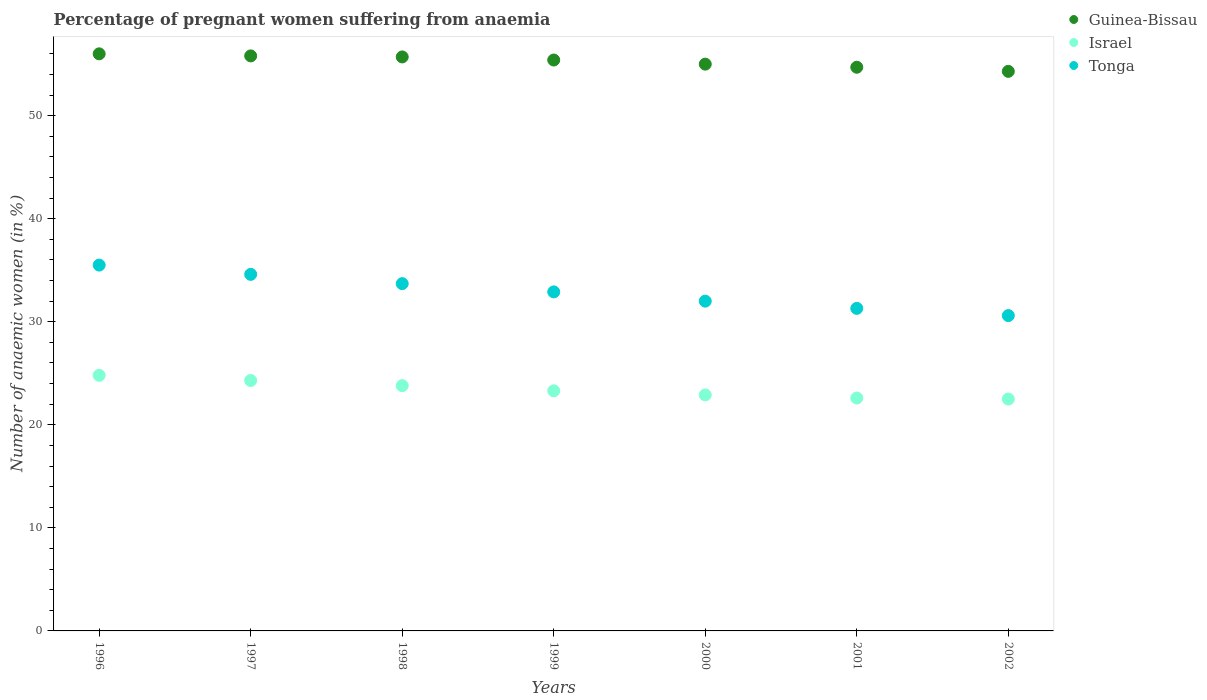How many different coloured dotlines are there?
Provide a succinct answer. 3. Is the number of dotlines equal to the number of legend labels?
Your answer should be very brief. Yes. What is the number of anaemic women in Guinea-Bissau in 2002?
Your answer should be very brief. 54.3. Across all years, what is the minimum number of anaemic women in Guinea-Bissau?
Your answer should be very brief. 54.3. In which year was the number of anaemic women in Tonga maximum?
Your answer should be very brief. 1996. What is the total number of anaemic women in Guinea-Bissau in the graph?
Your response must be concise. 386.9. What is the difference between the number of anaemic women in Israel in 2000 and that in 2001?
Your answer should be compact. 0.3. What is the difference between the number of anaemic women in Tonga in 1998 and the number of anaemic women in Guinea-Bissau in 2002?
Keep it short and to the point. -20.6. What is the average number of anaemic women in Israel per year?
Keep it short and to the point. 23.46. In the year 1998, what is the difference between the number of anaemic women in Guinea-Bissau and number of anaemic women in Israel?
Offer a very short reply. 31.9. In how many years, is the number of anaemic women in Guinea-Bissau greater than 18 %?
Your answer should be very brief. 7. What is the ratio of the number of anaemic women in Israel in 1998 to that in 2002?
Provide a short and direct response. 1.06. Is the number of anaemic women in Tonga in 1997 less than that in 1999?
Your answer should be compact. No. What is the difference between the highest and the second highest number of anaemic women in Guinea-Bissau?
Provide a succinct answer. 0.2. What is the difference between the highest and the lowest number of anaemic women in Tonga?
Give a very brief answer. 4.9. In how many years, is the number of anaemic women in Israel greater than the average number of anaemic women in Israel taken over all years?
Give a very brief answer. 3. How many years are there in the graph?
Offer a terse response. 7. What is the title of the graph?
Your answer should be very brief. Percentage of pregnant women suffering from anaemia. What is the label or title of the Y-axis?
Give a very brief answer. Number of anaemic women (in %). What is the Number of anaemic women (in %) in Israel in 1996?
Your answer should be compact. 24.8. What is the Number of anaemic women (in %) of Tonga in 1996?
Offer a very short reply. 35.5. What is the Number of anaemic women (in %) of Guinea-Bissau in 1997?
Ensure brevity in your answer.  55.8. What is the Number of anaemic women (in %) in Israel in 1997?
Provide a short and direct response. 24.3. What is the Number of anaemic women (in %) in Tonga in 1997?
Offer a very short reply. 34.6. What is the Number of anaemic women (in %) in Guinea-Bissau in 1998?
Give a very brief answer. 55.7. What is the Number of anaemic women (in %) in Israel in 1998?
Your answer should be very brief. 23.8. What is the Number of anaemic women (in %) in Tonga in 1998?
Keep it short and to the point. 33.7. What is the Number of anaemic women (in %) in Guinea-Bissau in 1999?
Offer a very short reply. 55.4. What is the Number of anaemic women (in %) of Israel in 1999?
Your response must be concise. 23.3. What is the Number of anaemic women (in %) of Tonga in 1999?
Your response must be concise. 32.9. What is the Number of anaemic women (in %) in Guinea-Bissau in 2000?
Offer a terse response. 55. What is the Number of anaemic women (in %) of Israel in 2000?
Give a very brief answer. 22.9. What is the Number of anaemic women (in %) of Guinea-Bissau in 2001?
Offer a terse response. 54.7. What is the Number of anaemic women (in %) in Israel in 2001?
Offer a terse response. 22.6. What is the Number of anaemic women (in %) of Tonga in 2001?
Make the answer very short. 31.3. What is the Number of anaemic women (in %) in Guinea-Bissau in 2002?
Make the answer very short. 54.3. What is the Number of anaemic women (in %) of Tonga in 2002?
Ensure brevity in your answer.  30.6. Across all years, what is the maximum Number of anaemic women (in %) of Israel?
Offer a terse response. 24.8. Across all years, what is the maximum Number of anaemic women (in %) in Tonga?
Provide a succinct answer. 35.5. Across all years, what is the minimum Number of anaemic women (in %) in Guinea-Bissau?
Give a very brief answer. 54.3. Across all years, what is the minimum Number of anaemic women (in %) in Israel?
Your answer should be very brief. 22.5. Across all years, what is the minimum Number of anaemic women (in %) of Tonga?
Provide a short and direct response. 30.6. What is the total Number of anaemic women (in %) in Guinea-Bissau in the graph?
Offer a very short reply. 386.9. What is the total Number of anaemic women (in %) in Israel in the graph?
Your response must be concise. 164.2. What is the total Number of anaemic women (in %) in Tonga in the graph?
Give a very brief answer. 230.6. What is the difference between the Number of anaemic women (in %) in Guinea-Bissau in 1996 and that in 1997?
Your answer should be very brief. 0.2. What is the difference between the Number of anaemic women (in %) of Tonga in 1996 and that in 1997?
Provide a short and direct response. 0.9. What is the difference between the Number of anaemic women (in %) in Israel in 1996 and that in 1998?
Provide a succinct answer. 1. What is the difference between the Number of anaemic women (in %) of Guinea-Bissau in 1996 and that in 1999?
Keep it short and to the point. 0.6. What is the difference between the Number of anaemic women (in %) in Tonga in 1996 and that in 1999?
Make the answer very short. 2.6. What is the difference between the Number of anaemic women (in %) of Tonga in 1996 and that in 2000?
Offer a terse response. 3.5. What is the difference between the Number of anaemic women (in %) in Tonga in 1996 and that in 2001?
Make the answer very short. 4.2. What is the difference between the Number of anaemic women (in %) in Guinea-Bissau in 1996 and that in 2002?
Your response must be concise. 1.7. What is the difference between the Number of anaemic women (in %) of Israel in 1997 and that in 1999?
Keep it short and to the point. 1. What is the difference between the Number of anaemic women (in %) in Tonga in 1997 and that in 1999?
Keep it short and to the point. 1.7. What is the difference between the Number of anaemic women (in %) in Guinea-Bissau in 1997 and that in 2000?
Offer a terse response. 0.8. What is the difference between the Number of anaemic women (in %) of Israel in 1997 and that in 2000?
Offer a very short reply. 1.4. What is the difference between the Number of anaemic women (in %) of Tonga in 1997 and that in 2000?
Provide a short and direct response. 2.6. What is the difference between the Number of anaemic women (in %) in Tonga in 1997 and that in 2001?
Provide a succinct answer. 3.3. What is the difference between the Number of anaemic women (in %) in Israel in 1997 and that in 2002?
Offer a terse response. 1.8. What is the difference between the Number of anaemic women (in %) in Tonga in 1998 and that in 1999?
Offer a terse response. 0.8. What is the difference between the Number of anaemic women (in %) of Guinea-Bissau in 1998 and that in 2000?
Provide a succinct answer. 0.7. What is the difference between the Number of anaemic women (in %) in Israel in 1998 and that in 2001?
Offer a terse response. 1.2. What is the difference between the Number of anaemic women (in %) in Israel in 1998 and that in 2002?
Provide a succinct answer. 1.3. What is the difference between the Number of anaemic women (in %) of Tonga in 1999 and that in 2000?
Make the answer very short. 0.9. What is the difference between the Number of anaemic women (in %) of Israel in 1999 and that in 2001?
Keep it short and to the point. 0.7. What is the difference between the Number of anaemic women (in %) of Israel in 1999 and that in 2002?
Your answer should be very brief. 0.8. What is the difference between the Number of anaemic women (in %) in Guinea-Bissau in 2000 and that in 2001?
Ensure brevity in your answer.  0.3. What is the difference between the Number of anaemic women (in %) in Tonga in 2000 and that in 2001?
Provide a short and direct response. 0.7. What is the difference between the Number of anaemic women (in %) of Israel in 2000 and that in 2002?
Ensure brevity in your answer.  0.4. What is the difference between the Number of anaemic women (in %) in Tonga in 2001 and that in 2002?
Give a very brief answer. 0.7. What is the difference between the Number of anaemic women (in %) of Guinea-Bissau in 1996 and the Number of anaemic women (in %) of Israel in 1997?
Your answer should be compact. 31.7. What is the difference between the Number of anaemic women (in %) in Guinea-Bissau in 1996 and the Number of anaemic women (in %) in Tonga in 1997?
Give a very brief answer. 21.4. What is the difference between the Number of anaemic women (in %) of Israel in 1996 and the Number of anaemic women (in %) of Tonga in 1997?
Provide a succinct answer. -9.8. What is the difference between the Number of anaemic women (in %) in Guinea-Bissau in 1996 and the Number of anaemic women (in %) in Israel in 1998?
Offer a terse response. 32.2. What is the difference between the Number of anaemic women (in %) in Guinea-Bissau in 1996 and the Number of anaemic women (in %) in Tonga in 1998?
Offer a very short reply. 22.3. What is the difference between the Number of anaemic women (in %) of Guinea-Bissau in 1996 and the Number of anaemic women (in %) of Israel in 1999?
Offer a very short reply. 32.7. What is the difference between the Number of anaemic women (in %) of Guinea-Bissau in 1996 and the Number of anaemic women (in %) of Tonga in 1999?
Provide a short and direct response. 23.1. What is the difference between the Number of anaemic women (in %) in Israel in 1996 and the Number of anaemic women (in %) in Tonga in 1999?
Keep it short and to the point. -8.1. What is the difference between the Number of anaemic women (in %) in Guinea-Bissau in 1996 and the Number of anaemic women (in %) in Israel in 2000?
Offer a very short reply. 33.1. What is the difference between the Number of anaemic women (in %) of Guinea-Bissau in 1996 and the Number of anaemic women (in %) of Tonga in 2000?
Offer a very short reply. 24. What is the difference between the Number of anaemic women (in %) of Israel in 1996 and the Number of anaemic women (in %) of Tonga in 2000?
Make the answer very short. -7.2. What is the difference between the Number of anaemic women (in %) of Guinea-Bissau in 1996 and the Number of anaemic women (in %) of Israel in 2001?
Your answer should be compact. 33.4. What is the difference between the Number of anaemic women (in %) in Guinea-Bissau in 1996 and the Number of anaemic women (in %) in Tonga in 2001?
Make the answer very short. 24.7. What is the difference between the Number of anaemic women (in %) in Guinea-Bissau in 1996 and the Number of anaemic women (in %) in Israel in 2002?
Give a very brief answer. 33.5. What is the difference between the Number of anaemic women (in %) of Guinea-Bissau in 1996 and the Number of anaemic women (in %) of Tonga in 2002?
Make the answer very short. 25.4. What is the difference between the Number of anaemic women (in %) of Israel in 1996 and the Number of anaemic women (in %) of Tonga in 2002?
Your answer should be compact. -5.8. What is the difference between the Number of anaemic women (in %) in Guinea-Bissau in 1997 and the Number of anaemic women (in %) in Tonga in 1998?
Your answer should be compact. 22.1. What is the difference between the Number of anaemic women (in %) in Israel in 1997 and the Number of anaemic women (in %) in Tonga in 1998?
Your answer should be very brief. -9.4. What is the difference between the Number of anaemic women (in %) of Guinea-Bissau in 1997 and the Number of anaemic women (in %) of Israel in 1999?
Ensure brevity in your answer.  32.5. What is the difference between the Number of anaemic women (in %) in Guinea-Bissau in 1997 and the Number of anaemic women (in %) in Tonga in 1999?
Offer a very short reply. 22.9. What is the difference between the Number of anaemic women (in %) of Guinea-Bissau in 1997 and the Number of anaemic women (in %) of Israel in 2000?
Provide a short and direct response. 32.9. What is the difference between the Number of anaemic women (in %) of Guinea-Bissau in 1997 and the Number of anaemic women (in %) of Tonga in 2000?
Make the answer very short. 23.8. What is the difference between the Number of anaemic women (in %) of Guinea-Bissau in 1997 and the Number of anaemic women (in %) of Israel in 2001?
Offer a terse response. 33.2. What is the difference between the Number of anaemic women (in %) in Israel in 1997 and the Number of anaemic women (in %) in Tonga in 2001?
Provide a short and direct response. -7. What is the difference between the Number of anaemic women (in %) of Guinea-Bissau in 1997 and the Number of anaemic women (in %) of Israel in 2002?
Offer a terse response. 33.3. What is the difference between the Number of anaemic women (in %) of Guinea-Bissau in 1997 and the Number of anaemic women (in %) of Tonga in 2002?
Your answer should be very brief. 25.2. What is the difference between the Number of anaemic women (in %) of Guinea-Bissau in 1998 and the Number of anaemic women (in %) of Israel in 1999?
Give a very brief answer. 32.4. What is the difference between the Number of anaemic women (in %) in Guinea-Bissau in 1998 and the Number of anaemic women (in %) in Tonga in 1999?
Offer a very short reply. 22.8. What is the difference between the Number of anaemic women (in %) in Israel in 1998 and the Number of anaemic women (in %) in Tonga in 1999?
Make the answer very short. -9.1. What is the difference between the Number of anaemic women (in %) of Guinea-Bissau in 1998 and the Number of anaemic women (in %) of Israel in 2000?
Offer a terse response. 32.8. What is the difference between the Number of anaemic women (in %) of Guinea-Bissau in 1998 and the Number of anaemic women (in %) of Tonga in 2000?
Ensure brevity in your answer.  23.7. What is the difference between the Number of anaemic women (in %) in Guinea-Bissau in 1998 and the Number of anaemic women (in %) in Israel in 2001?
Offer a very short reply. 33.1. What is the difference between the Number of anaemic women (in %) of Guinea-Bissau in 1998 and the Number of anaemic women (in %) of Tonga in 2001?
Ensure brevity in your answer.  24.4. What is the difference between the Number of anaemic women (in %) of Guinea-Bissau in 1998 and the Number of anaemic women (in %) of Israel in 2002?
Provide a short and direct response. 33.2. What is the difference between the Number of anaemic women (in %) in Guinea-Bissau in 1998 and the Number of anaemic women (in %) in Tonga in 2002?
Keep it short and to the point. 25.1. What is the difference between the Number of anaemic women (in %) in Guinea-Bissau in 1999 and the Number of anaemic women (in %) in Israel in 2000?
Make the answer very short. 32.5. What is the difference between the Number of anaemic women (in %) in Guinea-Bissau in 1999 and the Number of anaemic women (in %) in Tonga in 2000?
Give a very brief answer. 23.4. What is the difference between the Number of anaemic women (in %) of Israel in 1999 and the Number of anaemic women (in %) of Tonga in 2000?
Offer a terse response. -8.7. What is the difference between the Number of anaemic women (in %) in Guinea-Bissau in 1999 and the Number of anaemic women (in %) in Israel in 2001?
Provide a short and direct response. 32.8. What is the difference between the Number of anaemic women (in %) in Guinea-Bissau in 1999 and the Number of anaemic women (in %) in Tonga in 2001?
Offer a very short reply. 24.1. What is the difference between the Number of anaemic women (in %) in Guinea-Bissau in 1999 and the Number of anaemic women (in %) in Israel in 2002?
Your response must be concise. 32.9. What is the difference between the Number of anaemic women (in %) of Guinea-Bissau in 1999 and the Number of anaemic women (in %) of Tonga in 2002?
Provide a succinct answer. 24.8. What is the difference between the Number of anaemic women (in %) in Israel in 1999 and the Number of anaemic women (in %) in Tonga in 2002?
Make the answer very short. -7.3. What is the difference between the Number of anaemic women (in %) of Guinea-Bissau in 2000 and the Number of anaemic women (in %) of Israel in 2001?
Offer a very short reply. 32.4. What is the difference between the Number of anaemic women (in %) in Guinea-Bissau in 2000 and the Number of anaemic women (in %) in Tonga in 2001?
Provide a succinct answer. 23.7. What is the difference between the Number of anaemic women (in %) in Israel in 2000 and the Number of anaemic women (in %) in Tonga in 2001?
Your response must be concise. -8.4. What is the difference between the Number of anaemic women (in %) in Guinea-Bissau in 2000 and the Number of anaemic women (in %) in Israel in 2002?
Provide a short and direct response. 32.5. What is the difference between the Number of anaemic women (in %) in Guinea-Bissau in 2000 and the Number of anaemic women (in %) in Tonga in 2002?
Offer a terse response. 24.4. What is the difference between the Number of anaemic women (in %) of Guinea-Bissau in 2001 and the Number of anaemic women (in %) of Israel in 2002?
Make the answer very short. 32.2. What is the difference between the Number of anaemic women (in %) in Guinea-Bissau in 2001 and the Number of anaemic women (in %) in Tonga in 2002?
Ensure brevity in your answer.  24.1. What is the difference between the Number of anaemic women (in %) of Israel in 2001 and the Number of anaemic women (in %) of Tonga in 2002?
Your response must be concise. -8. What is the average Number of anaemic women (in %) in Guinea-Bissau per year?
Make the answer very short. 55.27. What is the average Number of anaemic women (in %) of Israel per year?
Offer a terse response. 23.46. What is the average Number of anaemic women (in %) of Tonga per year?
Your response must be concise. 32.94. In the year 1996, what is the difference between the Number of anaemic women (in %) of Guinea-Bissau and Number of anaemic women (in %) of Israel?
Provide a succinct answer. 31.2. In the year 1997, what is the difference between the Number of anaemic women (in %) of Guinea-Bissau and Number of anaemic women (in %) of Israel?
Your answer should be very brief. 31.5. In the year 1997, what is the difference between the Number of anaemic women (in %) of Guinea-Bissau and Number of anaemic women (in %) of Tonga?
Give a very brief answer. 21.2. In the year 1998, what is the difference between the Number of anaemic women (in %) of Guinea-Bissau and Number of anaemic women (in %) of Israel?
Give a very brief answer. 31.9. In the year 1999, what is the difference between the Number of anaemic women (in %) in Guinea-Bissau and Number of anaemic women (in %) in Israel?
Provide a short and direct response. 32.1. In the year 1999, what is the difference between the Number of anaemic women (in %) of Guinea-Bissau and Number of anaemic women (in %) of Tonga?
Give a very brief answer. 22.5. In the year 2000, what is the difference between the Number of anaemic women (in %) of Guinea-Bissau and Number of anaemic women (in %) of Israel?
Your answer should be compact. 32.1. In the year 2000, what is the difference between the Number of anaemic women (in %) of Guinea-Bissau and Number of anaemic women (in %) of Tonga?
Provide a succinct answer. 23. In the year 2000, what is the difference between the Number of anaemic women (in %) of Israel and Number of anaemic women (in %) of Tonga?
Make the answer very short. -9.1. In the year 2001, what is the difference between the Number of anaemic women (in %) in Guinea-Bissau and Number of anaemic women (in %) in Israel?
Give a very brief answer. 32.1. In the year 2001, what is the difference between the Number of anaemic women (in %) of Guinea-Bissau and Number of anaemic women (in %) of Tonga?
Give a very brief answer. 23.4. In the year 2002, what is the difference between the Number of anaemic women (in %) in Guinea-Bissau and Number of anaemic women (in %) in Israel?
Offer a terse response. 31.8. In the year 2002, what is the difference between the Number of anaemic women (in %) in Guinea-Bissau and Number of anaemic women (in %) in Tonga?
Make the answer very short. 23.7. What is the ratio of the Number of anaemic women (in %) in Israel in 1996 to that in 1997?
Provide a short and direct response. 1.02. What is the ratio of the Number of anaemic women (in %) of Guinea-Bissau in 1996 to that in 1998?
Give a very brief answer. 1.01. What is the ratio of the Number of anaemic women (in %) in Israel in 1996 to that in 1998?
Provide a succinct answer. 1.04. What is the ratio of the Number of anaemic women (in %) of Tonga in 1996 to that in 1998?
Offer a terse response. 1.05. What is the ratio of the Number of anaemic women (in %) of Guinea-Bissau in 1996 to that in 1999?
Your answer should be very brief. 1.01. What is the ratio of the Number of anaemic women (in %) of Israel in 1996 to that in 1999?
Your answer should be compact. 1.06. What is the ratio of the Number of anaemic women (in %) of Tonga in 1996 to that in 1999?
Offer a terse response. 1.08. What is the ratio of the Number of anaemic women (in %) in Guinea-Bissau in 1996 to that in 2000?
Your answer should be very brief. 1.02. What is the ratio of the Number of anaemic women (in %) of Israel in 1996 to that in 2000?
Ensure brevity in your answer.  1.08. What is the ratio of the Number of anaemic women (in %) in Tonga in 1996 to that in 2000?
Your response must be concise. 1.11. What is the ratio of the Number of anaemic women (in %) of Guinea-Bissau in 1996 to that in 2001?
Provide a short and direct response. 1.02. What is the ratio of the Number of anaemic women (in %) of Israel in 1996 to that in 2001?
Provide a succinct answer. 1.1. What is the ratio of the Number of anaemic women (in %) in Tonga in 1996 to that in 2001?
Ensure brevity in your answer.  1.13. What is the ratio of the Number of anaemic women (in %) of Guinea-Bissau in 1996 to that in 2002?
Provide a short and direct response. 1.03. What is the ratio of the Number of anaemic women (in %) of Israel in 1996 to that in 2002?
Your answer should be very brief. 1.1. What is the ratio of the Number of anaemic women (in %) of Tonga in 1996 to that in 2002?
Keep it short and to the point. 1.16. What is the ratio of the Number of anaemic women (in %) of Guinea-Bissau in 1997 to that in 1998?
Offer a terse response. 1. What is the ratio of the Number of anaemic women (in %) of Tonga in 1997 to that in 1998?
Your answer should be compact. 1.03. What is the ratio of the Number of anaemic women (in %) in Israel in 1997 to that in 1999?
Give a very brief answer. 1.04. What is the ratio of the Number of anaemic women (in %) of Tonga in 1997 to that in 1999?
Your response must be concise. 1.05. What is the ratio of the Number of anaemic women (in %) of Guinea-Bissau in 1997 to that in 2000?
Provide a short and direct response. 1.01. What is the ratio of the Number of anaemic women (in %) of Israel in 1997 to that in 2000?
Keep it short and to the point. 1.06. What is the ratio of the Number of anaemic women (in %) of Tonga in 1997 to that in 2000?
Offer a terse response. 1.08. What is the ratio of the Number of anaemic women (in %) in Guinea-Bissau in 1997 to that in 2001?
Make the answer very short. 1.02. What is the ratio of the Number of anaemic women (in %) in Israel in 1997 to that in 2001?
Keep it short and to the point. 1.08. What is the ratio of the Number of anaemic women (in %) in Tonga in 1997 to that in 2001?
Your answer should be very brief. 1.11. What is the ratio of the Number of anaemic women (in %) in Guinea-Bissau in 1997 to that in 2002?
Provide a short and direct response. 1.03. What is the ratio of the Number of anaemic women (in %) in Tonga in 1997 to that in 2002?
Your answer should be very brief. 1.13. What is the ratio of the Number of anaemic women (in %) of Guinea-Bissau in 1998 to that in 1999?
Your answer should be very brief. 1.01. What is the ratio of the Number of anaemic women (in %) in Israel in 1998 to that in 1999?
Give a very brief answer. 1.02. What is the ratio of the Number of anaemic women (in %) in Tonga in 1998 to that in 1999?
Your answer should be compact. 1.02. What is the ratio of the Number of anaemic women (in %) of Guinea-Bissau in 1998 to that in 2000?
Provide a short and direct response. 1.01. What is the ratio of the Number of anaemic women (in %) in Israel in 1998 to that in 2000?
Your answer should be compact. 1.04. What is the ratio of the Number of anaemic women (in %) of Tonga in 1998 to that in 2000?
Offer a very short reply. 1.05. What is the ratio of the Number of anaemic women (in %) of Guinea-Bissau in 1998 to that in 2001?
Your answer should be compact. 1.02. What is the ratio of the Number of anaemic women (in %) of Israel in 1998 to that in 2001?
Make the answer very short. 1.05. What is the ratio of the Number of anaemic women (in %) of Tonga in 1998 to that in 2001?
Make the answer very short. 1.08. What is the ratio of the Number of anaemic women (in %) in Guinea-Bissau in 1998 to that in 2002?
Your answer should be compact. 1.03. What is the ratio of the Number of anaemic women (in %) in Israel in 1998 to that in 2002?
Your response must be concise. 1.06. What is the ratio of the Number of anaemic women (in %) in Tonga in 1998 to that in 2002?
Provide a short and direct response. 1.1. What is the ratio of the Number of anaemic women (in %) of Guinea-Bissau in 1999 to that in 2000?
Your answer should be very brief. 1.01. What is the ratio of the Number of anaemic women (in %) in Israel in 1999 to that in 2000?
Offer a terse response. 1.02. What is the ratio of the Number of anaemic women (in %) in Tonga in 1999 to that in 2000?
Give a very brief answer. 1.03. What is the ratio of the Number of anaemic women (in %) of Guinea-Bissau in 1999 to that in 2001?
Keep it short and to the point. 1.01. What is the ratio of the Number of anaemic women (in %) of Israel in 1999 to that in 2001?
Offer a very short reply. 1.03. What is the ratio of the Number of anaemic women (in %) of Tonga in 1999 to that in 2001?
Offer a very short reply. 1.05. What is the ratio of the Number of anaemic women (in %) of Guinea-Bissau in 1999 to that in 2002?
Provide a succinct answer. 1.02. What is the ratio of the Number of anaemic women (in %) in Israel in 1999 to that in 2002?
Provide a short and direct response. 1.04. What is the ratio of the Number of anaemic women (in %) in Tonga in 1999 to that in 2002?
Your answer should be compact. 1.08. What is the ratio of the Number of anaemic women (in %) of Israel in 2000 to that in 2001?
Give a very brief answer. 1.01. What is the ratio of the Number of anaemic women (in %) in Tonga in 2000 to that in 2001?
Your response must be concise. 1.02. What is the ratio of the Number of anaemic women (in %) of Guinea-Bissau in 2000 to that in 2002?
Offer a very short reply. 1.01. What is the ratio of the Number of anaemic women (in %) in Israel in 2000 to that in 2002?
Keep it short and to the point. 1.02. What is the ratio of the Number of anaemic women (in %) in Tonga in 2000 to that in 2002?
Provide a short and direct response. 1.05. What is the ratio of the Number of anaemic women (in %) in Guinea-Bissau in 2001 to that in 2002?
Provide a short and direct response. 1.01. What is the ratio of the Number of anaemic women (in %) of Israel in 2001 to that in 2002?
Provide a short and direct response. 1. What is the ratio of the Number of anaemic women (in %) of Tonga in 2001 to that in 2002?
Keep it short and to the point. 1.02. What is the difference between the highest and the second highest Number of anaemic women (in %) in Israel?
Ensure brevity in your answer.  0.5. What is the difference between the highest and the second highest Number of anaemic women (in %) of Tonga?
Your answer should be compact. 0.9. What is the difference between the highest and the lowest Number of anaemic women (in %) of Guinea-Bissau?
Keep it short and to the point. 1.7. What is the difference between the highest and the lowest Number of anaemic women (in %) in Israel?
Keep it short and to the point. 2.3. What is the difference between the highest and the lowest Number of anaemic women (in %) of Tonga?
Make the answer very short. 4.9. 